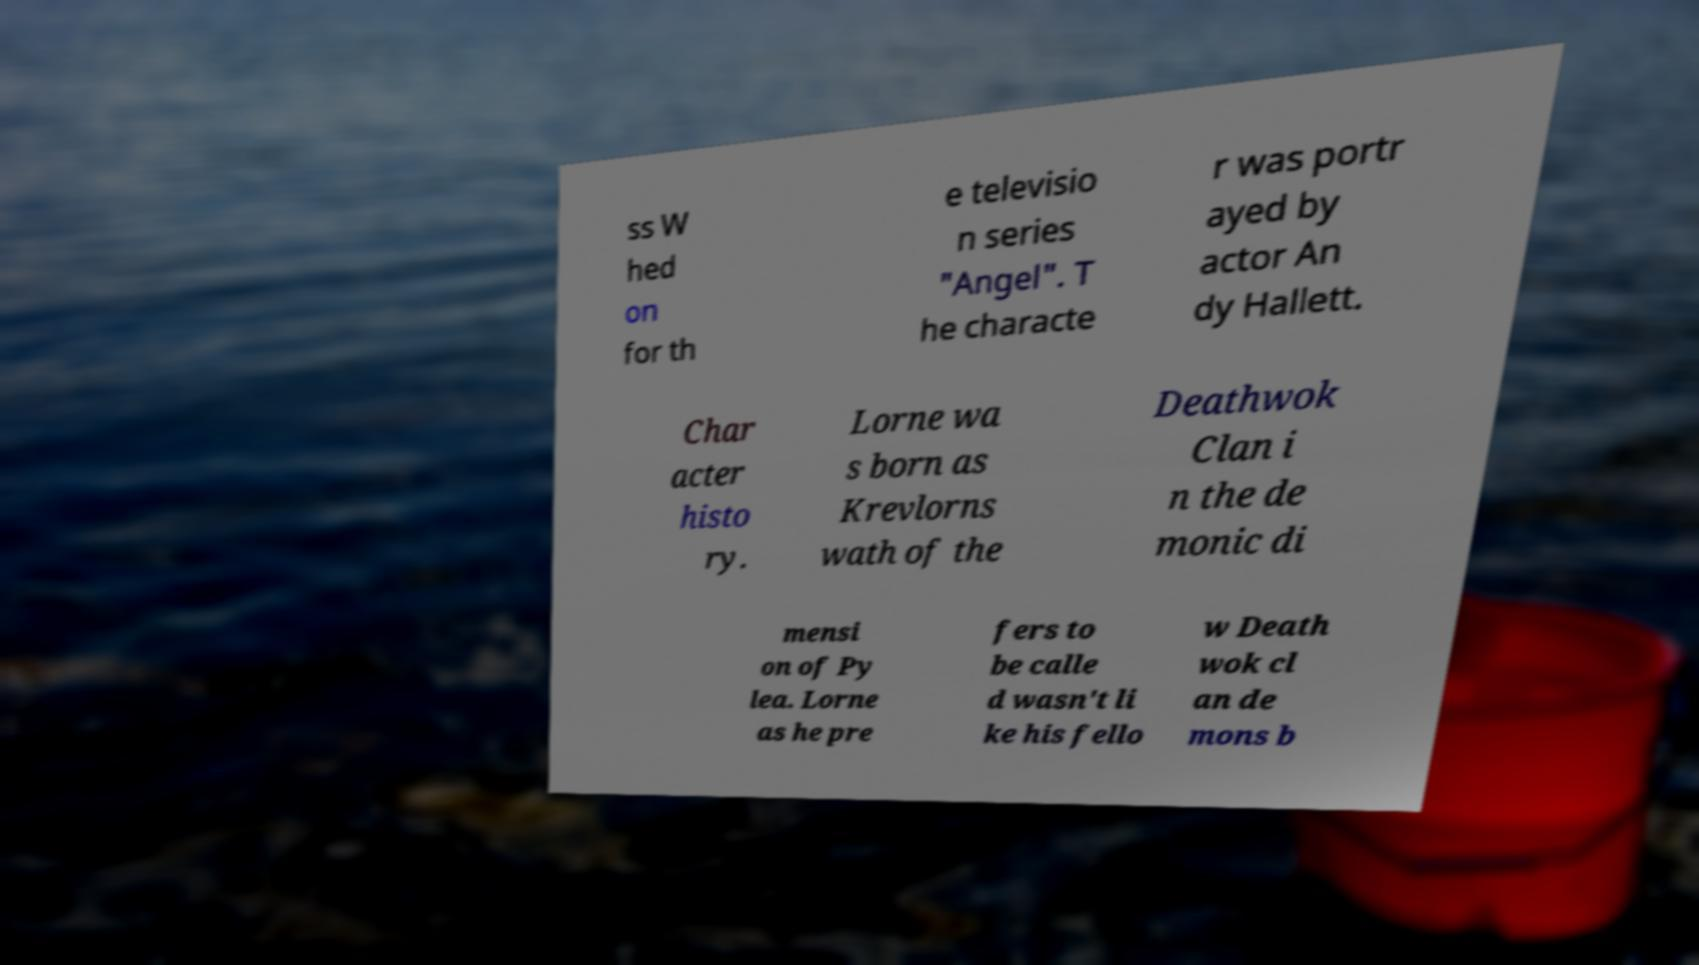Can you read and provide the text displayed in the image?This photo seems to have some interesting text. Can you extract and type it out for me? ss W hed on for th e televisio n series "Angel". T he characte r was portr ayed by actor An dy Hallett. Char acter histo ry. Lorne wa s born as Krevlorns wath of the Deathwok Clan i n the de monic di mensi on of Py lea. Lorne as he pre fers to be calle d wasn't li ke his fello w Death wok cl an de mons b 